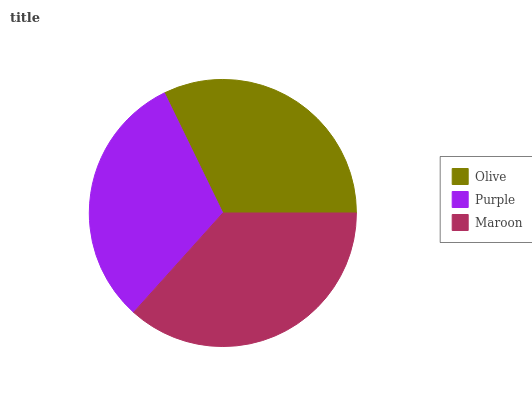Is Purple the minimum?
Answer yes or no. Yes. Is Maroon the maximum?
Answer yes or no. Yes. Is Maroon the minimum?
Answer yes or no. No. Is Purple the maximum?
Answer yes or no. No. Is Maroon greater than Purple?
Answer yes or no. Yes. Is Purple less than Maroon?
Answer yes or no. Yes. Is Purple greater than Maroon?
Answer yes or no. No. Is Maroon less than Purple?
Answer yes or no. No. Is Olive the high median?
Answer yes or no. Yes. Is Olive the low median?
Answer yes or no. Yes. Is Purple the high median?
Answer yes or no. No. Is Purple the low median?
Answer yes or no. No. 